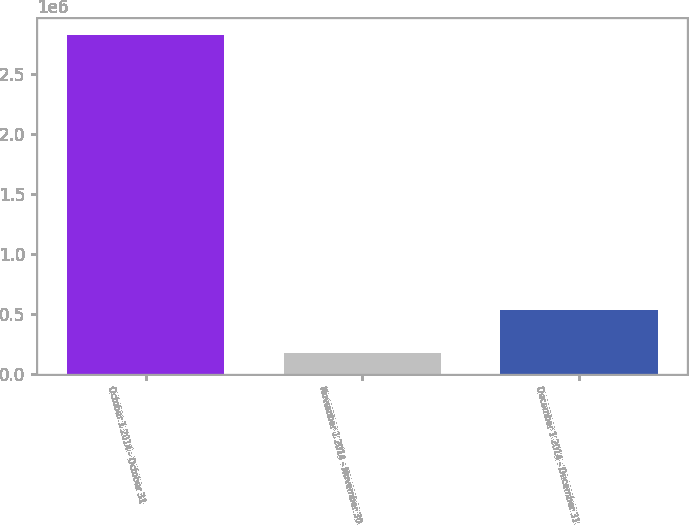<chart> <loc_0><loc_0><loc_500><loc_500><bar_chart><fcel>October 1 2014 - October 31<fcel>November 1 2014 - November 30<fcel>December 1 2014 - December 31<nl><fcel>2.82545e+06<fcel>177300<fcel>533340<nl></chart> 